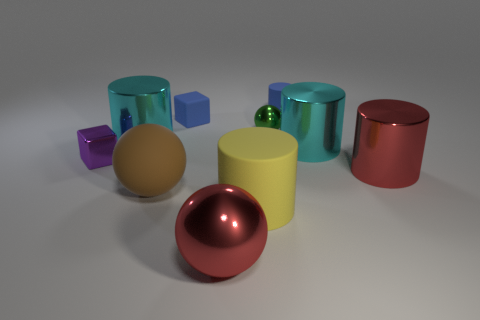There is a big object that is the same color as the big metal ball; what shape is it?
Provide a short and direct response. Cylinder. There is a big red metal thing that is behind the large brown rubber ball; are there any tiny shiny blocks that are left of it?
Your answer should be very brief. Yes. Are there any large cyan shiny objects?
Keep it short and to the point. Yes. What number of red metallic things have the same size as the rubber block?
Your answer should be very brief. 0. What number of big metal objects are in front of the small metal cube and right of the tiny green metallic ball?
Keep it short and to the point. 1. Is the size of the blue thing that is to the right of the blue matte block the same as the big red metallic ball?
Offer a terse response. No. Is there a tiny block of the same color as the small shiny sphere?
Your answer should be very brief. No. There is a yellow cylinder that is made of the same material as the brown sphere; what size is it?
Offer a terse response. Large. Are there more cyan objects in front of the tiny green metallic object than tiny purple cubes in front of the small purple shiny block?
Offer a terse response. Yes. What number of other objects are the same material as the purple object?
Offer a very short reply. 5. 